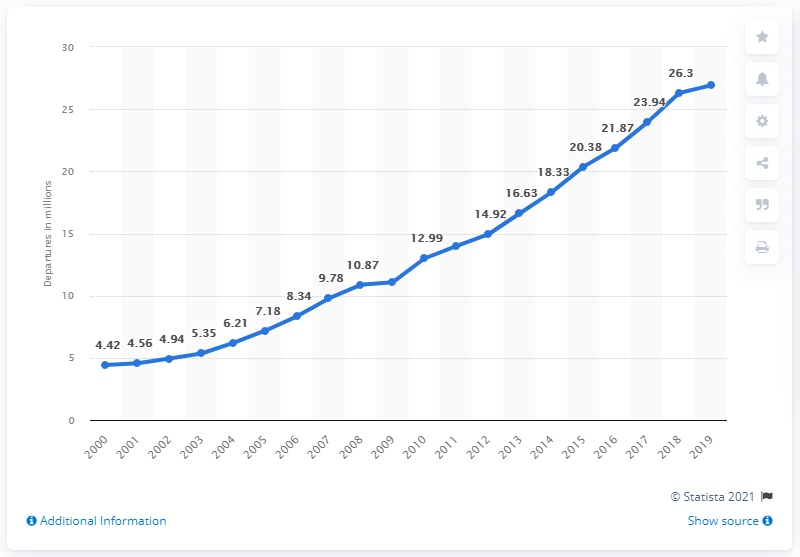Identify some key points in this picture. In 2019, 26,920 Indian nationals left India, according to the latest available data. 